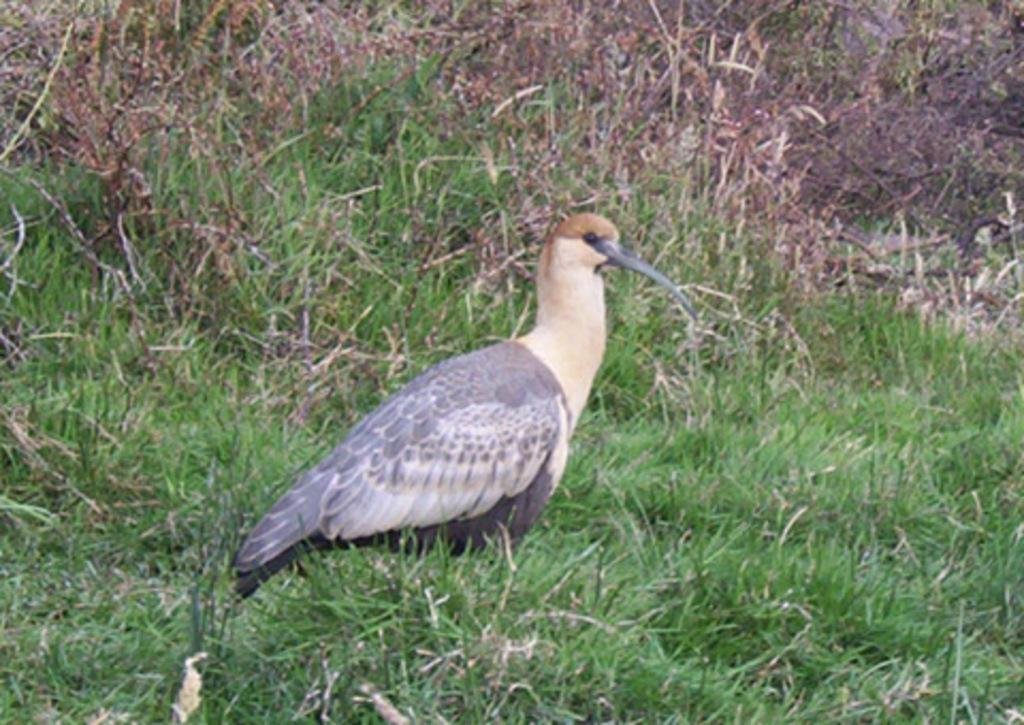What type of animal can be seen in the image? There is a bird in the image. Where is the bird located in the image? The bird is on a grass path. What type of stove can be seen in the image? There is no stove present in the image; it features a bird on a grass path. What type of clouds can be seen in the image? There is no mention of clouds in the image; it features a bird on a grass path. 